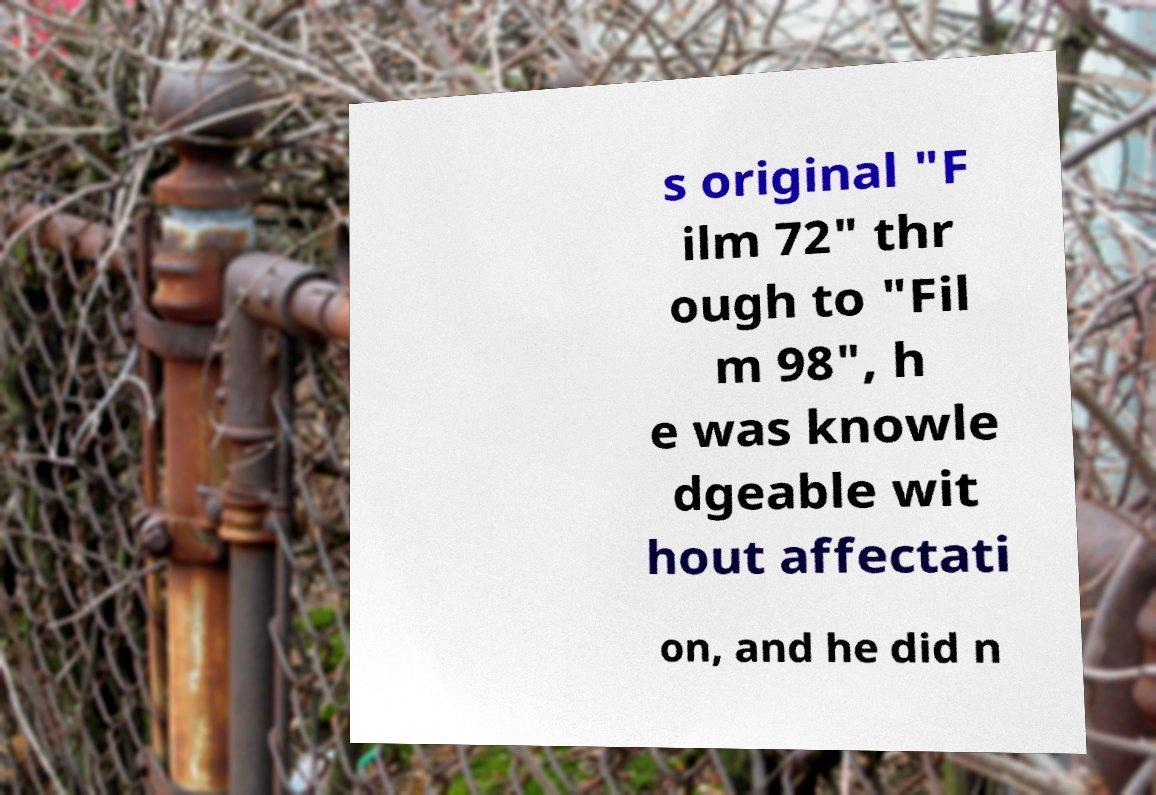Could you assist in decoding the text presented in this image and type it out clearly? s original "F ilm 72" thr ough to "Fil m 98", h e was knowle dgeable wit hout affectati on, and he did n 